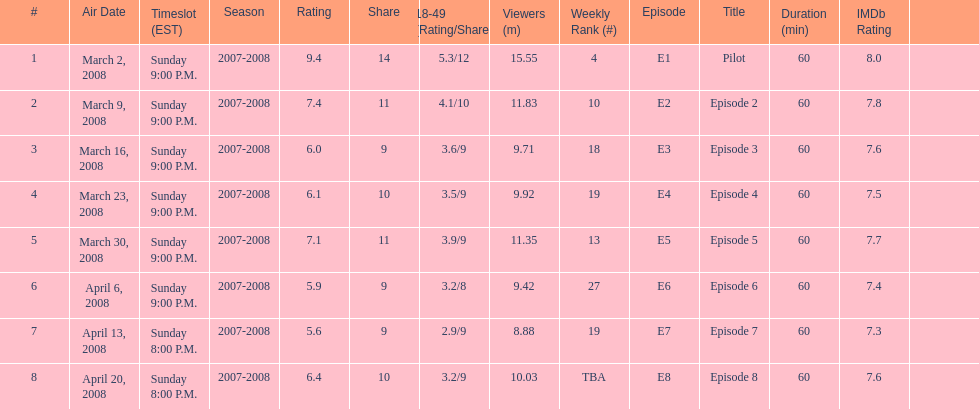Which air date had the least viewers? April 13, 2008. 